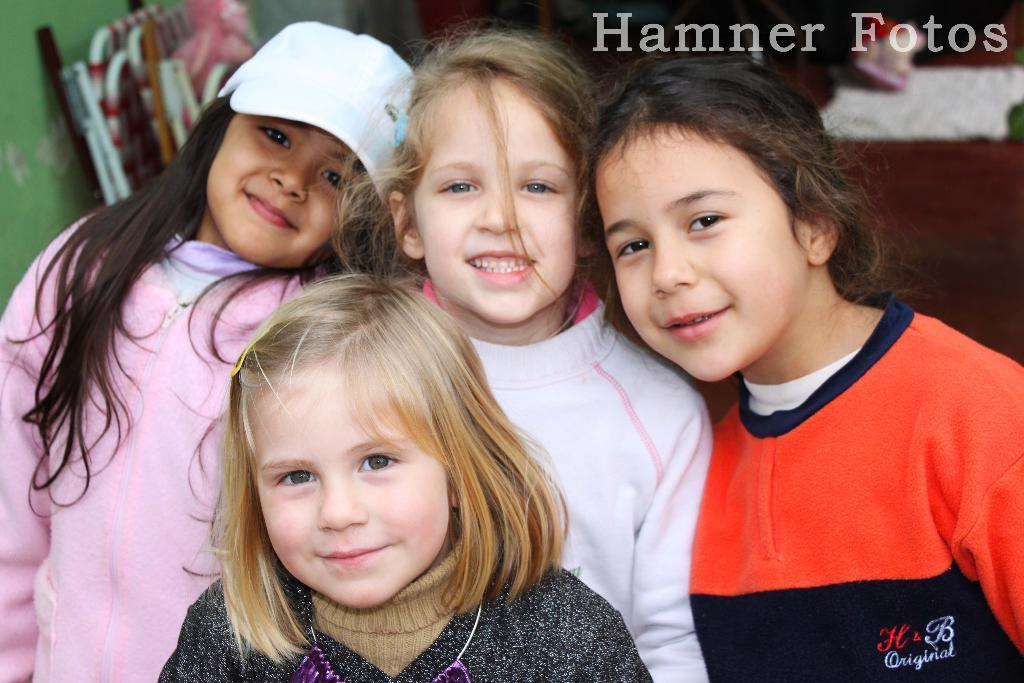Who is present in the image? There are girls in the image. What can be seen in the background of the image? There are chairs in the background of the image. Where is the text located in the image? The text is in the top right side of the image. What type of holiday is the group of girls experiencing in the image? There is no indication of a holiday or any experience in the image; it simply shows girls and chairs in the background. 